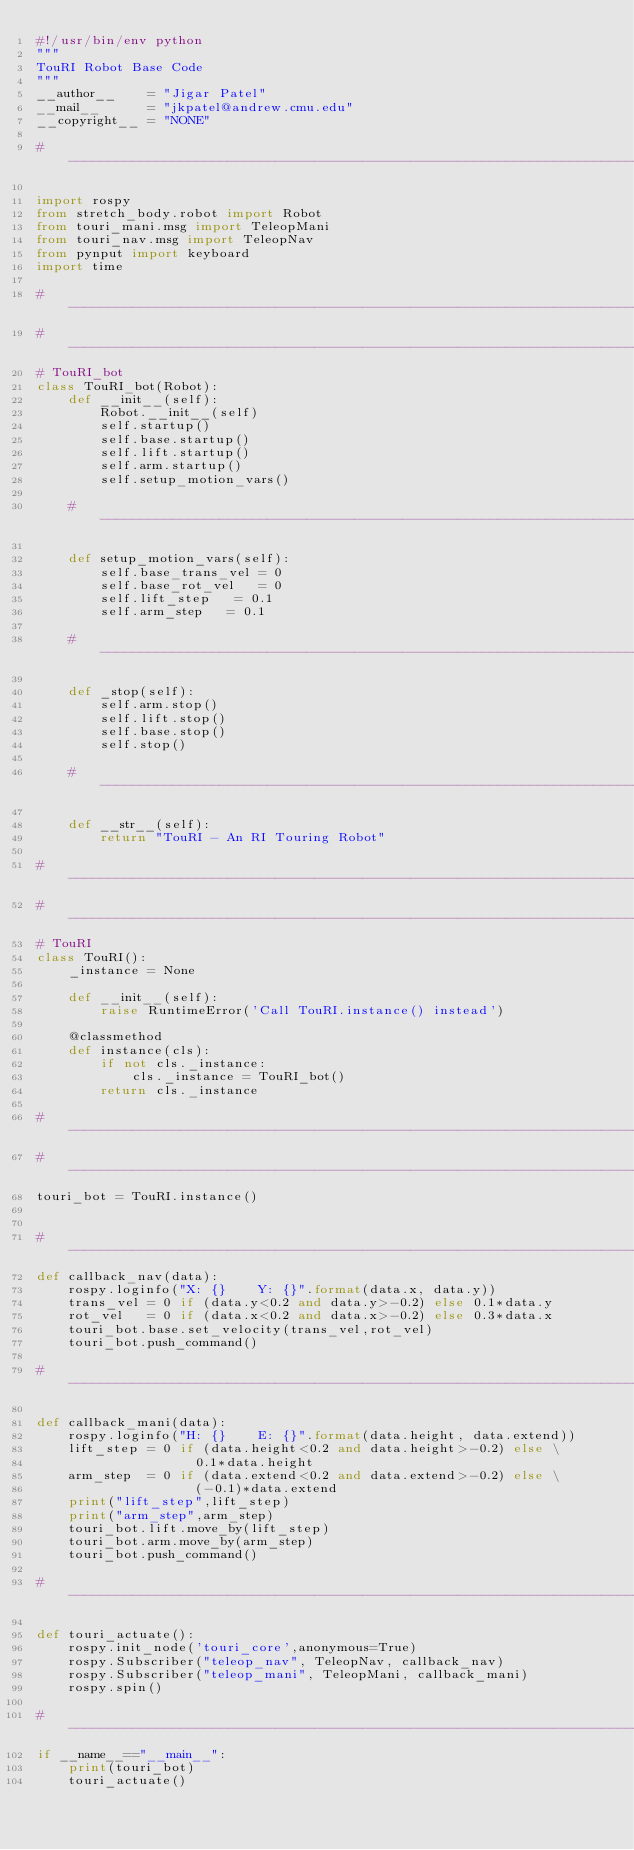<code> <loc_0><loc_0><loc_500><loc_500><_Python_>#!/usr/bin/env python
"""
TouRI Robot Base Code
"""
__author__    = "Jigar Patel"
__mail__      = "jkpatel@andrew.cmu.edu"
__copyright__ = "NONE"

# -----------------------------------------------------------------------------

import rospy
from stretch_body.robot import Robot
from touri_mani.msg import TeleopMani
from touri_nav.msg import TeleopNav
from pynput import keyboard
import time

# -----------------------------------------------------------------------------
# -----------------------------------------------------------------------------
# TouRI_bot
class TouRI_bot(Robot):
    def __init__(self):
        Robot.__init__(self)
        self.startup()
        self.base.startup()
        self.lift.startup()
        self.arm.startup()
        self.setup_motion_vars()
    
    # -------------------------------------------------------------------------

    def setup_motion_vars(self):
        self.base_trans_vel = 0
        self.base_rot_vel   = 0
        self.lift_step   = 0.1
        self.arm_step   = 0.1
    
    # -------------------------------------------------------------------------

    def _stop(self):
        self.arm.stop()
        self.lift.stop()
        self.base.stop()
        self.stop()

    # -------------------------------------------------------------------------

    def __str__(self):
        return "TouRI - An RI Touring Robot"

# -----------------------------------------------------------------------------
# -----------------------------------------------------------------------------
# TouRI
class TouRI():
    _instance = None

    def __init__(self):
        raise RuntimeError('Call TouRI.instance() instead')

    @classmethod
    def instance(cls):
        if not cls._instance:
            cls._instance = TouRI_bot()
        return cls._instance

# -----------------------------------------------------------------------------
# -----------------------------------------------------------------------------
touri_bot = TouRI.instance()


# -----------------------------------------------------------------------------
def callback_nav(data):
    rospy.loginfo("X: {}    Y: {}".format(data.x, data.y))
    trans_vel = 0 if (data.y<0.2 and data.y>-0.2) else 0.1*data.y
    rot_vel   = 0 if (data.x<0.2 and data.x>-0.2) else 0.3*data.x
    touri_bot.base.set_velocity(trans_vel,rot_vel)
    touri_bot.push_command()

# -----------------------------------------------------------------------------

def callback_mani(data):
    rospy.loginfo("H: {}    E: {}".format(data.height, data.extend))
    lift_step = 0 if (data.height<0.2 and data.height>-0.2) else \
                    0.1*data.height
    arm_step  = 0 if (data.extend<0.2 and data.extend>-0.2) else \
                    (-0.1)*data.extend
    print("lift_step",lift_step)
    print("arm_step",arm_step)
    touri_bot.lift.move_by(lift_step)
    touri_bot.arm.move_by(arm_step)
    touri_bot.push_command()

# -----------------------------------------------------------------------------

def touri_actuate():
    rospy.init_node('touri_core',anonymous=True)
    rospy.Subscriber("teleop_nav", TeleopNav, callback_nav)
    rospy.Subscriber("teleop_mani", TeleopMani, callback_mani)
    rospy.spin()

# -----------------------------------------------------------------------------
if __name__=="__main__":
    print(touri_bot)
    touri_actuate()

</code> 